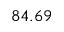Convert formula to latex. <formula><loc_0><loc_0><loc_500><loc_500>8 4 . 6 9</formula> 